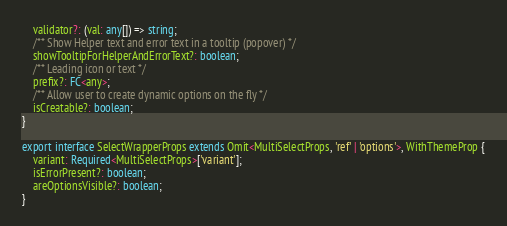Convert code to text. <code><loc_0><loc_0><loc_500><loc_500><_TypeScript_>    validator?: (val: any[]) => string;
    /** Show Helper text and error text in a tooltip (popover) */
    showTooltipForHelperAndErrorText?: boolean;
    /** Leading icon or text */
    prefix?: FC<any>;
    /** Allow user to create dynamic options on the fly */
    isCreatable?: boolean;
}

export interface SelectWrapperProps extends Omit<MultiSelectProps, 'ref' | 'options'>, WithThemeProp {
    variant: Required<MultiSelectProps>['variant'];
    isErrorPresent?: boolean;
    areOptionsVisible?: boolean;
}
</code> 